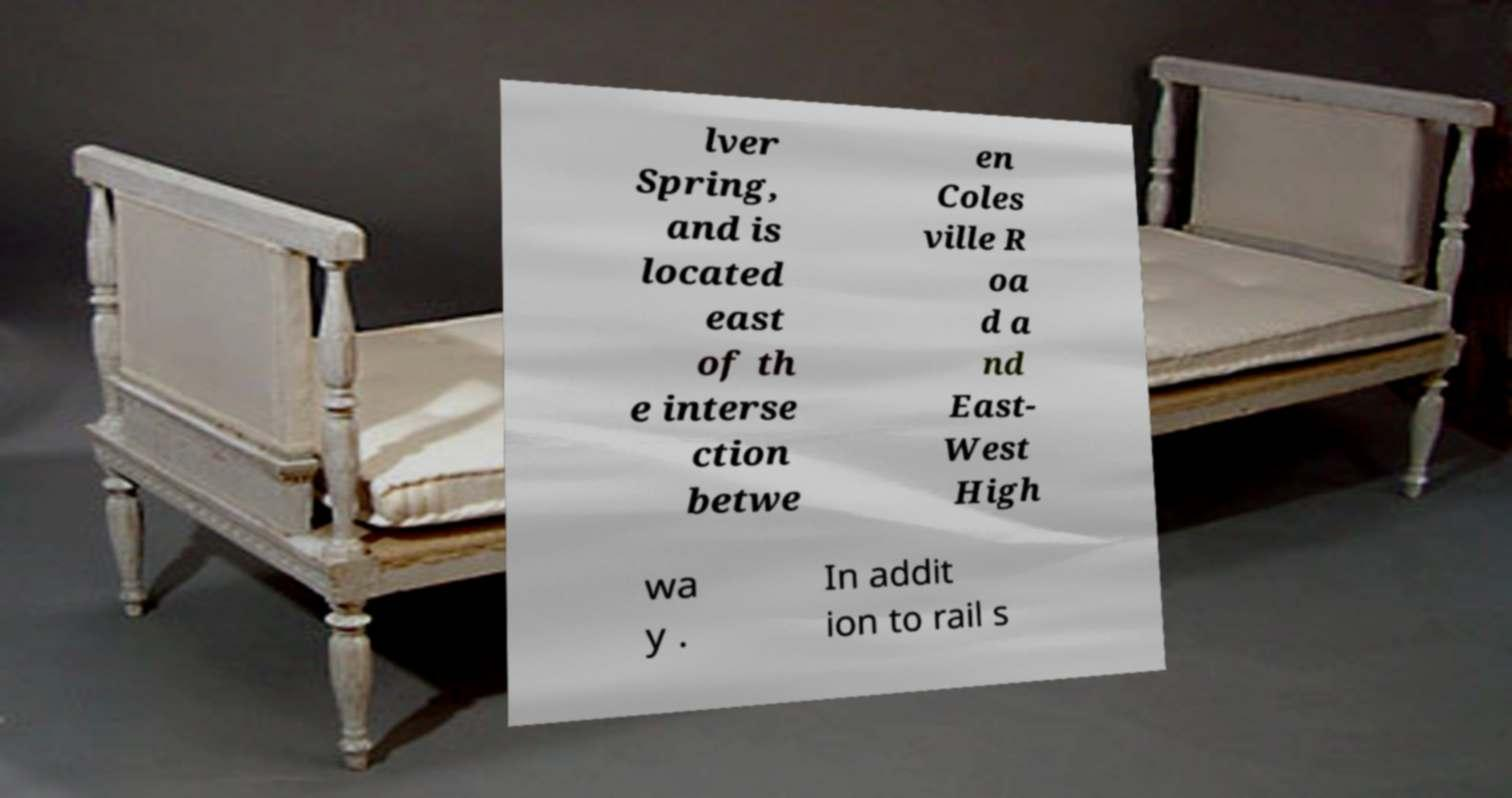Could you assist in decoding the text presented in this image and type it out clearly? lver Spring, and is located east of th e interse ction betwe en Coles ville R oa d a nd East- West High wa y . In addit ion to rail s 